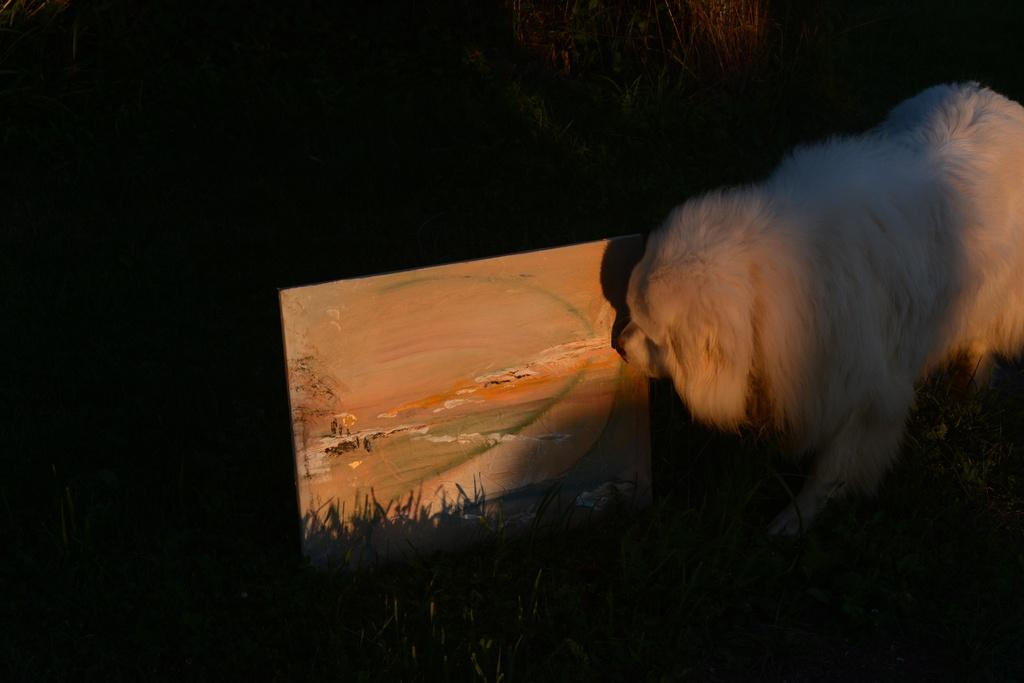What type of animal is on the right side of the image? There is a dog on the right side of the image. What is the main subject in the center of the image? There is a portrait in the center of the image. What type of railway is depicted in the portrait? There is no railway present in the image, as the main subject in the center is a portrait, not a railway. 